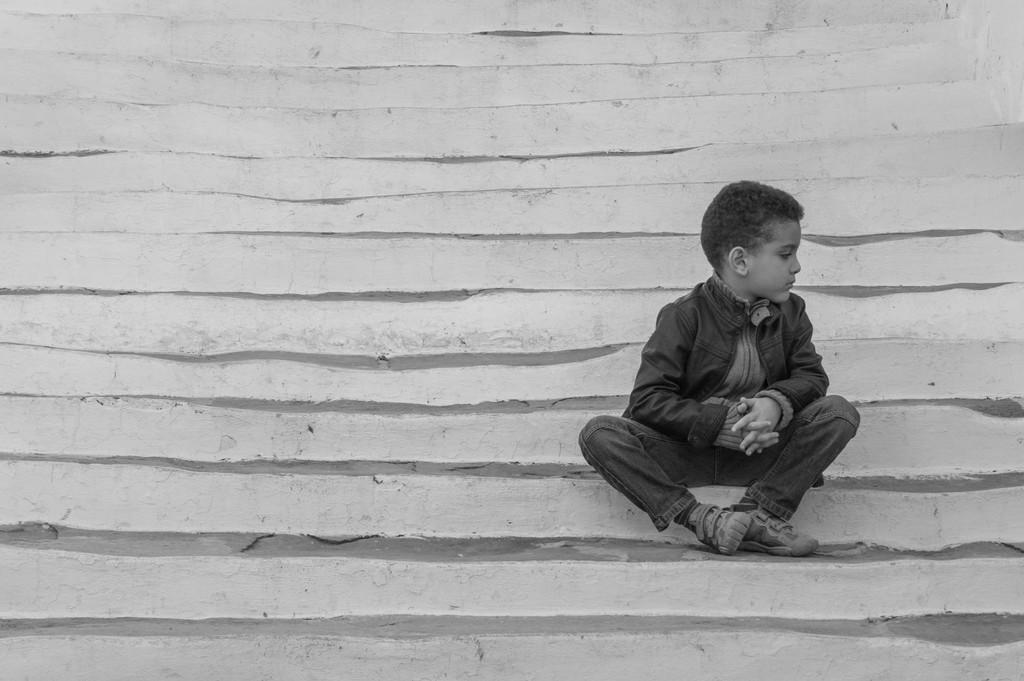Please provide a concise description of this image. There is a small boy sitting on the stairs in the foreground area of the image. 